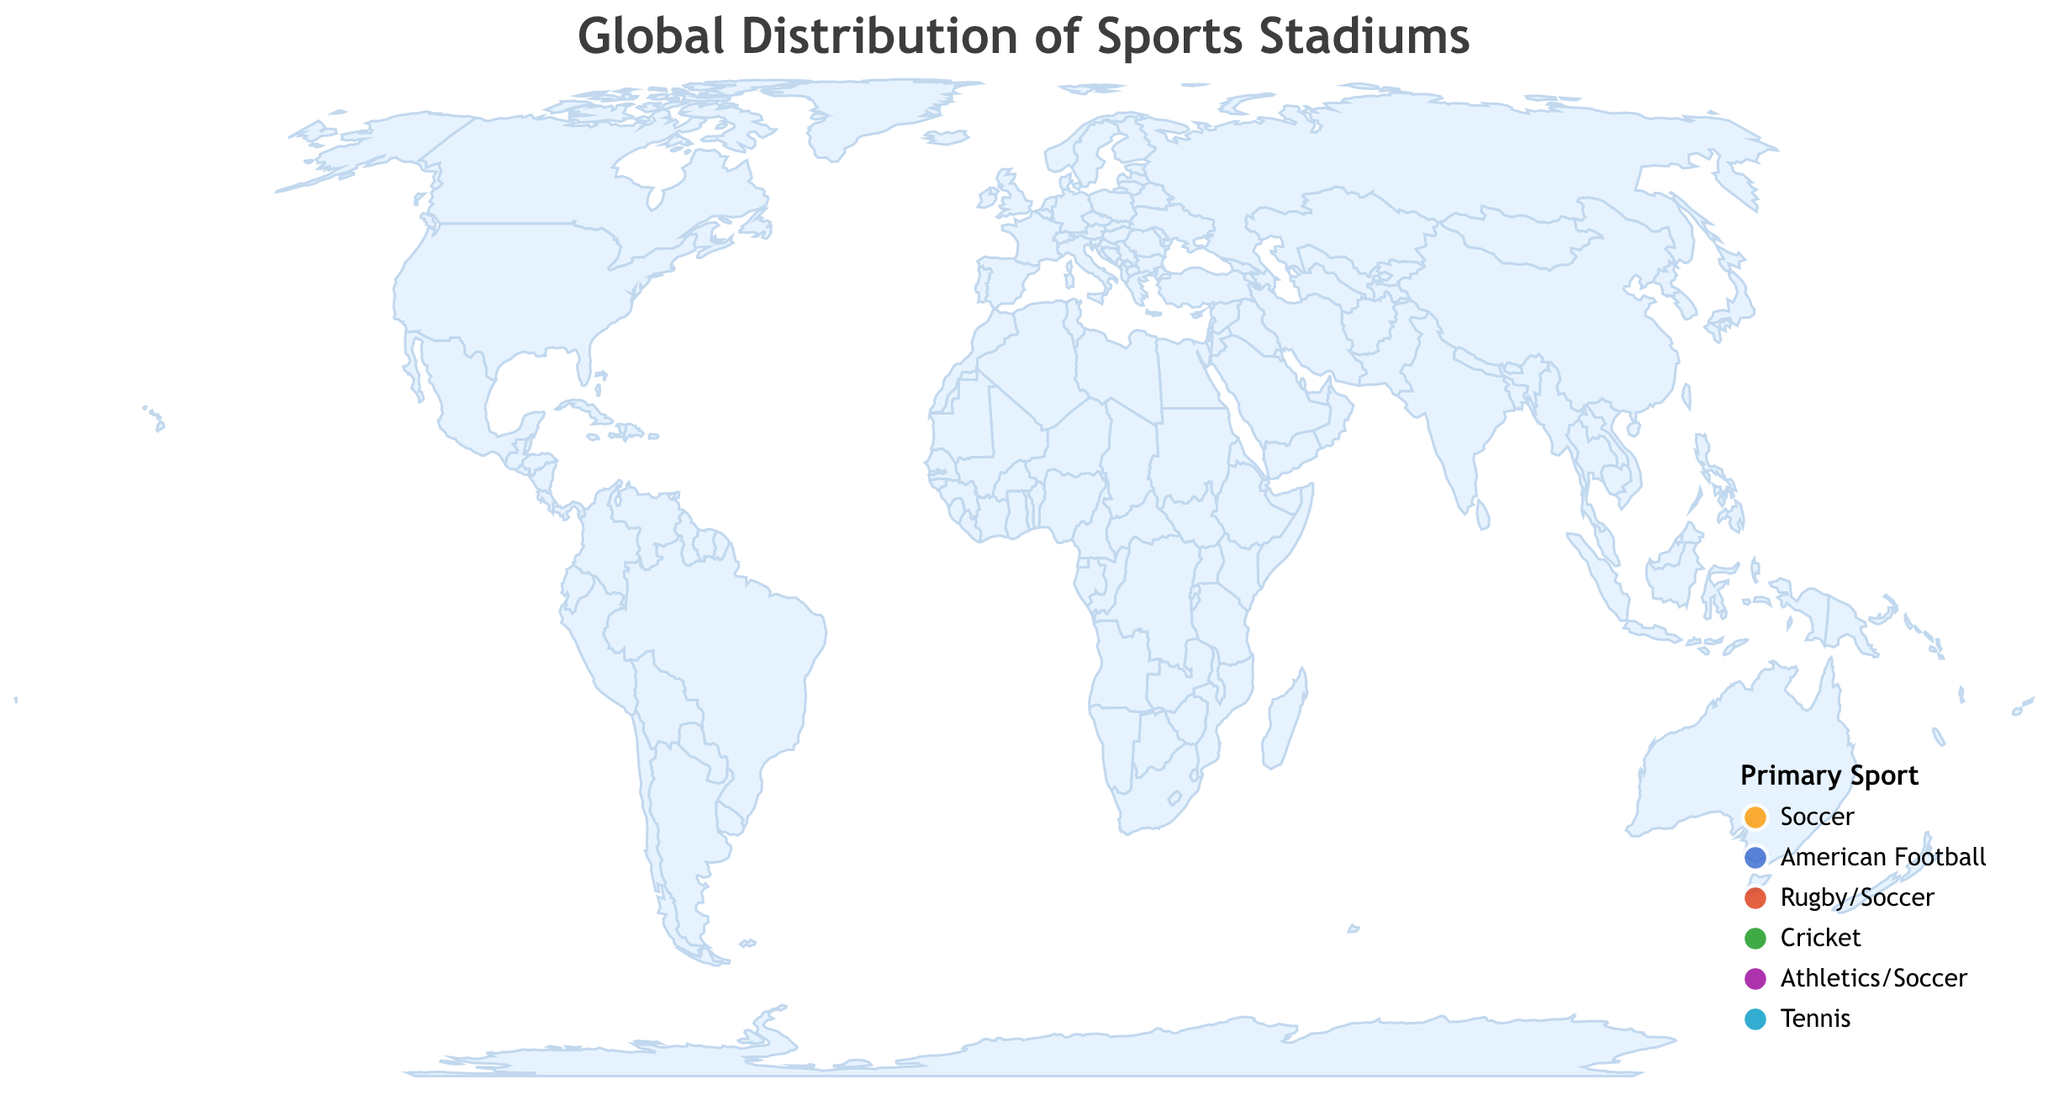What's the title of the figure? The title is usually placed prominently at the top of the figure and describes what the figure is about. In this case, the title is specified clearly in the code.
Answer: "Global Distribution of Sports Stadiums" Which stadium has the largest capacity in the figure? We need to identify the stadium with the highest capacity value among all listed data points. Camp Nou in Barcelona has a capacity of 99,354.
Answer: Camp Nou What is the primary sport of Stade Olympico in Rome, Italy? We locate Stadio Olimpico in the tooltip or the data and check the associated primary sport.
Answer: Soccer How many American Football stadiums are displayed on the map? By counting the circled data points in the legend with the color representing "American Football," which are Heinz Field and Hard Rock Stadium.
Answer: 2 Which stadium has the smallest capacity, and what sport is primarily played there? By examining the capacity values or using the tooltip, we find Arthur Ashe Stadium in New York with a capacity of 23,771, where Tennis is the primary sport.
Answer: Arthur Ashe Stadium, Tennis What is the average capacity of soccer stadiums displayed in the figure? First, add the capacities of all soccer stadiums: Emirates Stadium (60,704), Ernst-Happel-Stadion (50,865), Stadio Olimpico (70,634), Maracanã Stadium (78,838), Celtic Park (60,411), Olympiastadion (74,475), Estadio Ramón Sánchez Pizjuán (43,883), and Camp Nou (99,354). Sum = 539,164. Then divide by the number of soccer stadiums (8). 539,164 / 8 = 67,395.5
Answer: 67,395.5 Which city is home to the stadium with the second-largest capacity? By inspecting the capacity values and their corresponding stadiums, we find Maracanã Stadium in Rio de Janeiro, Brazil, with a capacity of 78,838 is the second largest.
Answer: Rio de Janeiro How does the capacity of the Hard Rock Stadium compare to Heinz Field? By comparing their capacities, Hard Rock Stadium has a capacity of 65,326 and Heinz Field has 68,400. Heinz Field has a larger capacity than Hard Rock Stadium.
Answer: Heinz Field has a larger capacity Which continent has the highest number of stadiums shown on this map? By looking at the geographic locations of the stadiums, Europe has the highest number with stadiums in the UK, Austria, Italy, Scotland, Germany, and Spain.
Answer: Europe 